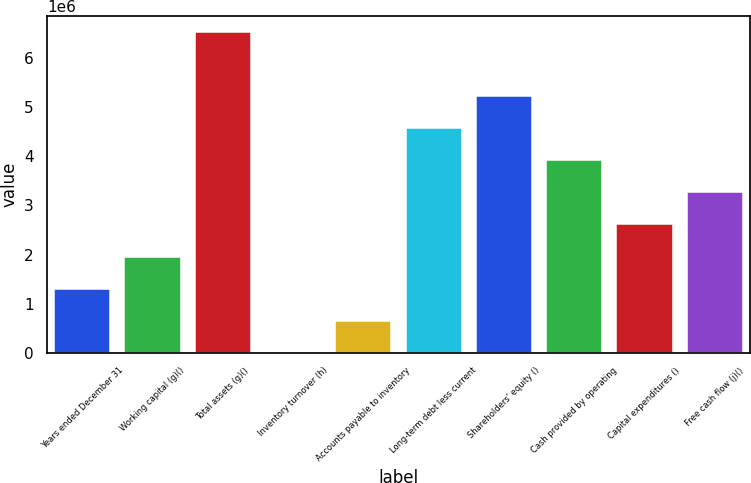<chart> <loc_0><loc_0><loc_500><loc_500><bar_chart><fcel>Years ended December 31<fcel>Working capital (g)()<fcel>Total assets (g)()<fcel>Inventory turnover (h)<fcel>Accounts payable to inventory<fcel>Long-term debt less current<fcel>Shareholders' equity ()<fcel>Cash provided by operating<fcel>Capital expenditures ()<fcel>Free cash flow (j)()<nl><fcel>1.30642e+06<fcel>1.95963e+06<fcel>6.53208e+06<fcel>1.4<fcel>653210<fcel>4.57246e+06<fcel>5.22567e+06<fcel>3.91925e+06<fcel>2.61283e+06<fcel>3.26604e+06<nl></chart> 